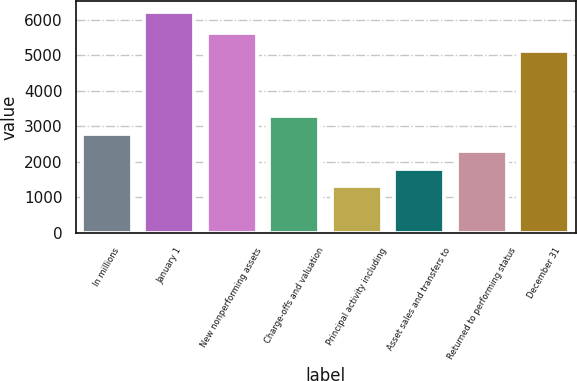<chart> <loc_0><loc_0><loc_500><loc_500><bar_chart><fcel>In millions<fcel>January 1<fcel>New nonperforming assets<fcel>Charge-offs and valuation<fcel>Principal activity including<fcel>Asset sales and transfers to<fcel>Returned to performing status<fcel>December 31<nl><fcel>2782.4<fcel>6204<fcel>5611.8<fcel>3271.2<fcel>1316<fcel>1804.8<fcel>2293.6<fcel>5123<nl></chart> 